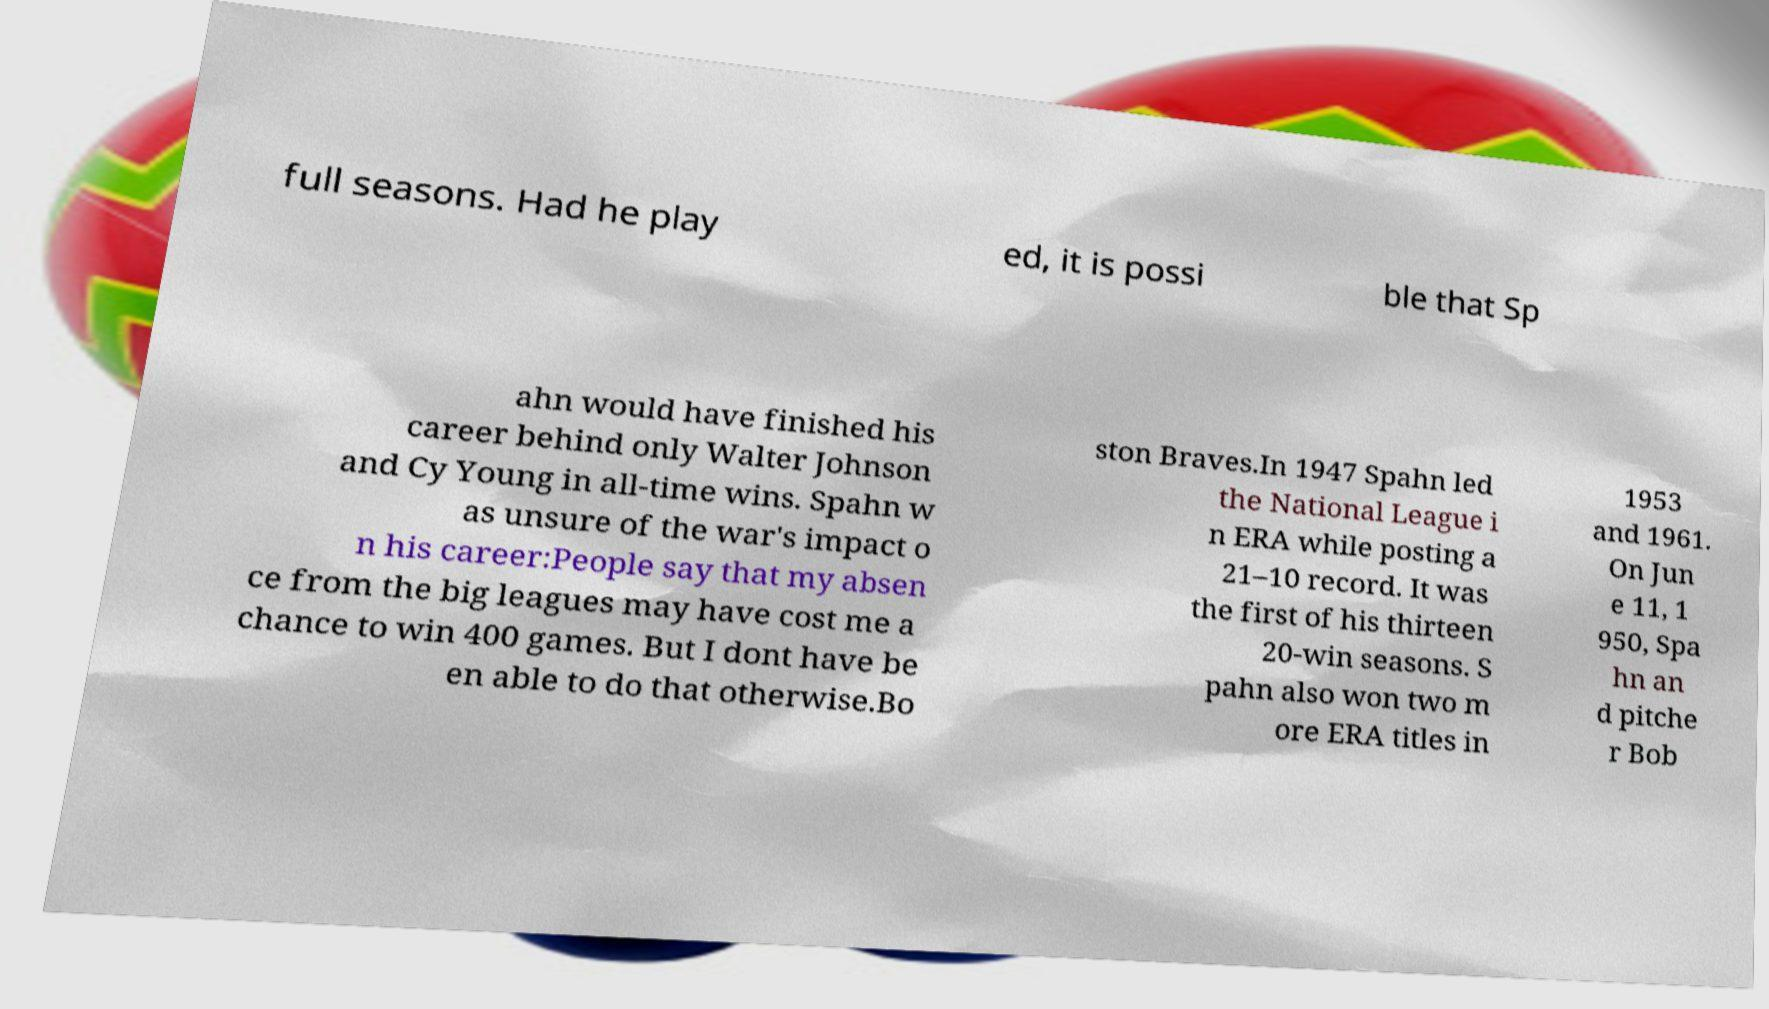Please identify and transcribe the text found in this image. full seasons. Had he play ed, it is possi ble that Sp ahn would have finished his career behind only Walter Johnson and Cy Young in all-time wins. Spahn w as unsure of the war's impact o n his career:People say that my absen ce from the big leagues may have cost me a chance to win 400 games. But I dont have be en able to do that otherwise.Bo ston Braves.In 1947 Spahn led the National League i n ERA while posting a 21–10 record. It was the first of his thirteen 20-win seasons. S pahn also won two m ore ERA titles in 1953 and 1961. On Jun e 11, 1 950, Spa hn an d pitche r Bob 